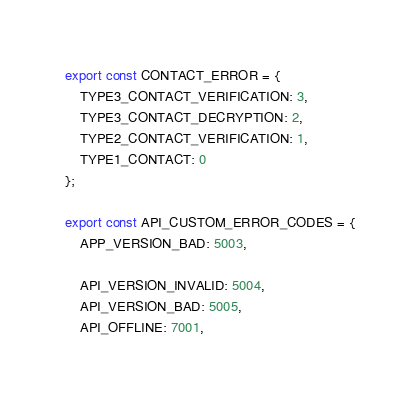Convert code to text. <code><loc_0><loc_0><loc_500><loc_500><_JavaScript_>export const CONTACT_ERROR = {
    TYPE3_CONTACT_VERIFICATION: 3,
    TYPE3_CONTACT_DECRYPTION: 2,
    TYPE2_CONTACT_VERIFICATION: 1,
    TYPE1_CONTACT: 0
};

export const API_CUSTOM_ERROR_CODES = {
    APP_VERSION_BAD: 5003,

    API_VERSION_INVALID: 5004,
    API_VERSION_BAD: 5005,
    API_OFFLINE: 7001,
</code> 